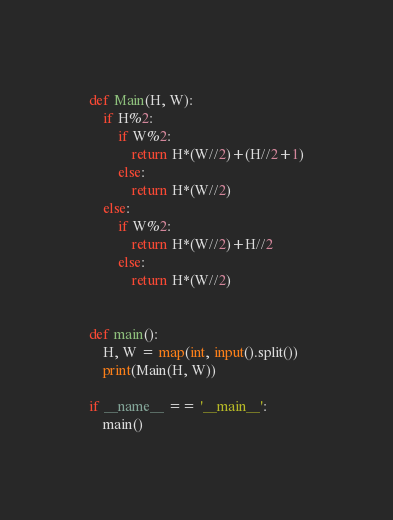<code> <loc_0><loc_0><loc_500><loc_500><_Python_>def Main(H, W):
    if H%2:
        if W%2:
            return H*(W//2)+(H//2+1)
        else:
            return H*(W//2)
    else:
        if W%2:
            return H*(W//2)+H//2
        else:
            return H*(W//2)
                

def main():
    H, W = map(int, input().split())
    print(Main(H, W))

if __name__ == '__main__':
    main()</code> 